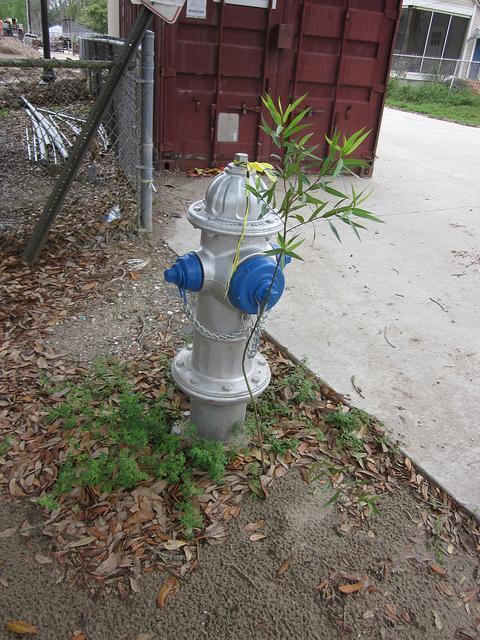How many fire hydrants can you see?
Give a very brief answer. 1. How many pizzas are on the man's bike?
Give a very brief answer. 0. 